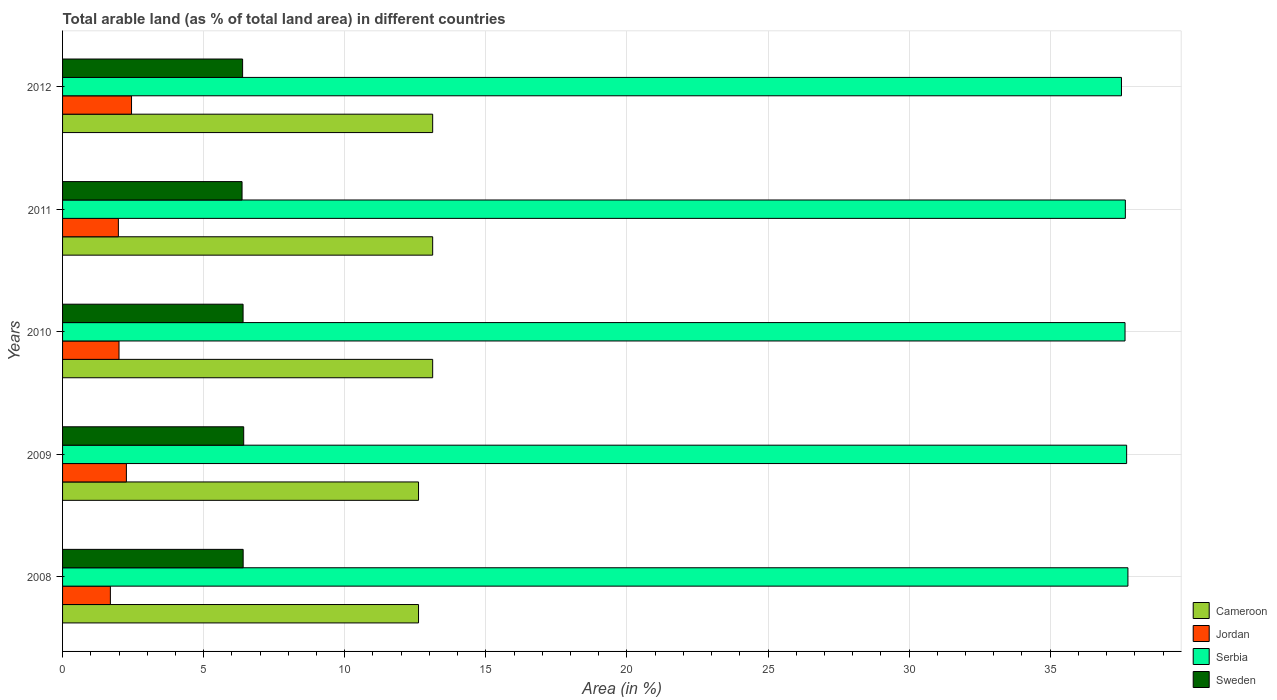How many different coloured bars are there?
Your answer should be compact. 4. How many groups of bars are there?
Offer a very short reply. 5. Are the number of bars per tick equal to the number of legend labels?
Make the answer very short. Yes. How many bars are there on the 2nd tick from the bottom?
Offer a terse response. 4. What is the label of the 4th group of bars from the top?
Your answer should be very brief. 2009. What is the percentage of arable land in Jordan in 2012?
Your answer should be very brief. 2.44. Across all years, what is the maximum percentage of arable land in Serbia?
Your response must be concise. 37.75. Across all years, what is the minimum percentage of arable land in Serbia?
Offer a terse response. 37.53. In which year was the percentage of arable land in Sweden maximum?
Your answer should be compact. 2009. In which year was the percentage of arable land in Serbia minimum?
Your answer should be very brief. 2012. What is the total percentage of arable land in Jordan in the graph?
Your answer should be compact. 10.38. What is the difference between the percentage of arable land in Sweden in 2009 and that in 2011?
Provide a short and direct response. 0.06. What is the difference between the percentage of arable land in Jordan in 2010 and the percentage of arable land in Cameroon in 2012?
Provide a short and direct response. -11.12. What is the average percentage of arable land in Jordan per year?
Keep it short and to the point. 2.08. In the year 2009, what is the difference between the percentage of arable land in Serbia and percentage of arable land in Cameroon?
Make the answer very short. 25.09. What is the ratio of the percentage of arable land in Sweden in 2010 to that in 2012?
Your answer should be very brief. 1. What is the difference between the highest and the second highest percentage of arable land in Sweden?
Your answer should be very brief. 0.02. What is the difference between the highest and the lowest percentage of arable land in Sweden?
Your response must be concise. 0.06. In how many years, is the percentage of arable land in Jordan greater than the average percentage of arable land in Jordan taken over all years?
Give a very brief answer. 2. Is the sum of the percentage of arable land in Jordan in 2009 and 2010 greater than the maximum percentage of arable land in Serbia across all years?
Offer a very short reply. No. What does the 1st bar from the bottom in 2008 represents?
Give a very brief answer. Cameroon. Is it the case that in every year, the sum of the percentage of arable land in Serbia and percentage of arable land in Sweden is greater than the percentage of arable land in Cameroon?
Your answer should be compact. Yes. How many bars are there?
Make the answer very short. 20. How are the legend labels stacked?
Your answer should be compact. Vertical. What is the title of the graph?
Keep it short and to the point. Total arable land (as % of total land area) in different countries. What is the label or title of the X-axis?
Provide a short and direct response. Area (in %). What is the Area (in %) in Cameroon in 2008?
Offer a very short reply. 12.61. What is the Area (in %) of Jordan in 2008?
Your response must be concise. 1.69. What is the Area (in %) of Serbia in 2008?
Make the answer very short. 37.75. What is the Area (in %) of Sweden in 2008?
Your answer should be very brief. 6.4. What is the Area (in %) in Cameroon in 2009?
Your response must be concise. 12.61. What is the Area (in %) in Jordan in 2009?
Provide a succinct answer. 2.26. What is the Area (in %) in Serbia in 2009?
Your answer should be compact. 37.71. What is the Area (in %) of Sweden in 2009?
Your answer should be very brief. 6.42. What is the Area (in %) in Cameroon in 2010?
Make the answer very short. 13.12. What is the Area (in %) in Jordan in 2010?
Offer a terse response. 2. What is the Area (in %) of Serbia in 2010?
Make the answer very short. 37.65. What is the Area (in %) of Sweden in 2010?
Ensure brevity in your answer.  6.4. What is the Area (in %) in Cameroon in 2011?
Your response must be concise. 13.12. What is the Area (in %) in Jordan in 2011?
Provide a short and direct response. 1.98. What is the Area (in %) of Serbia in 2011?
Your answer should be very brief. 37.66. What is the Area (in %) of Sweden in 2011?
Make the answer very short. 6.36. What is the Area (in %) of Cameroon in 2012?
Ensure brevity in your answer.  13.12. What is the Area (in %) of Jordan in 2012?
Your answer should be compact. 2.44. What is the Area (in %) of Serbia in 2012?
Offer a very short reply. 37.53. What is the Area (in %) of Sweden in 2012?
Ensure brevity in your answer.  6.38. Across all years, what is the maximum Area (in %) of Cameroon?
Offer a very short reply. 13.12. Across all years, what is the maximum Area (in %) in Jordan?
Offer a very short reply. 2.44. Across all years, what is the maximum Area (in %) in Serbia?
Your answer should be very brief. 37.75. Across all years, what is the maximum Area (in %) of Sweden?
Your answer should be very brief. 6.42. Across all years, what is the minimum Area (in %) of Cameroon?
Provide a short and direct response. 12.61. Across all years, what is the minimum Area (in %) in Jordan?
Ensure brevity in your answer.  1.69. Across all years, what is the minimum Area (in %) in Serbia?
Make the answer very short. 37.53. Across all years, what is the minimum Area (in %) of Sweden?
Give a very brief answer. 6.36. What is the total Area (in %) of Cameroon in the graph?
Provide a succinct answer. 64.58. What is the total Area (in %) of Jordan in the graph?
Offer a very short reply. 10.38. What is the total Area (in %) of Serbia in the graph?
Provide a succinct answer. 188.3. What is the total Area (in %) of Sweden in the graph?
Ensure brevity in your answer.  31.96. What is the difference between the Area (in %) in Jordan in 2008 and that in 2009?
Ensure brevity in your answer.  -0.57. What is the difference between the Area (in %) in Serbia in 2008 and that in 2009?
Keep it short and to the point. 0.05. What is the difference between the Area (in %) in Sweden in 2008 and that in 2009?
Ensure brevity in your answer.  -0.02. What is the difference between the Area (in %) in Cameroon in 2008 and that in 2010?
Offer a very short reply. -0.5. What is the difference between the Area (in %) of Jordan in 2008 and that in 2010?
Your response must be concise. -0.31. What is the difference between the Area (in %) of Serbia in 2008 and that in 2010?
Give a very brief answer. 0.1. What is the difference between the Area (in %) in Sweden in 2008 and that in 2010?
Offer a very short reply. 0. What is the difference between the Area (in %) in Cameroon in 2008 and that in 2011?
Your answer should be compact. -0.5. What is the difference between the Area (in %) of Jordan in 2008 and that in 2011?
Your response must be concise. -0.28. What is the difference between the Area (in %) in Serbia in 2008 and that in 2011?
Keep it short and to the point. 0.09. What is the difference between the Area (in %) of Sweden in 2008 and that in 2011?
Make the answer very short. 0.04. What is the difference between the Area (in %) in Cameroon in 2008 and that in 2012?
Ensure brevity in your answer.  -0.5. What is the difference between the Area (in %) in Jordan in 2008 and that in 2012?
Keep it short and to the point. -0.75. What is the difference between the Area (in %) of Serbia in 2008 and that in 2012?
Ensure brevity in your answer.  0.23. What is the difference between the Area (in %) in Sweden in 2008 and that in 2012?
Provide a succinct answer. 0.02. What is the difference between the Area (in %) of Cameroon in 2009 and that in 2010?
Your answer should be very brief. -0.5. What is the difference between the Area (in %) in Jordan in 2009 and that in 2010?
Your answer should be very brief. 0.26. What is the difference between the Area (in %) of Serbia in 2009 and that in 2010?
Give a very brief answer. 0.06. What is the difference between the Area (in %) in Sweden in 2009 and that in 2010?
Your answer should be very brief. 0.02. What is the difference between the Area (in %) in Cameroon in 2009 and that in 2011?
Your response must be concise. -0.5. What is the difference between the Area (in %) in Jordan in 2009 and that in 2011?
Make the answer very short. 0.28. What is the difference between the Area (in %) of Serbia in 2009 and that in 2011?
Keep it short and to the point. 0.05. What is the difference between the Area (in %) in Sweden in 2009 and that in 2011?
Your answer should be compact. 0.06. What is the difference between the Area (in %) in Cameroon in 2009 and that in 2012?
Provide a short and direct response. -0.5. What is the difference between the Area (in %) in Jordan in 2009 and that in 2012?
Provide a succinct answer. -0.18. What is the difference between the Area (in %) of Serbia in 2009 and that in 2012?
Offer a very short reply. 0.18. What is the difference between the Area (in %) in Sweden in 2009 and that in 2012?
Give a very brief answer. 0.04. What is the difference between the Area (in %) in Jordan in 2010 and that in 2011?
Your answer should be compact. 0.02. What is the difference between the Area (in %) in Serbia in 2010 and that in 2011?
Keep it short and to the point. -0.01. What is the difference between the Area (in %) of Sweden in 2010 and that in 2011?
Ensure brevity in your answer.  0.04. What is the difference between the Area (in %) in Jordan in 2010 and that in 2012?
Provide a succinct answer. -0.44. What is the difference between the Area (in %) in Serbia in 2010 and that in 2012?
Offer a very short reply. 0.13. What is the difference between the Area (in %) in Sweden in 2010 and that in 2012?
Your response must be concise. 0.02. What is the difference between the Area (in %) in Cameroon in 2011 and that in 2012?
Your response must be concise. 0. What is the difference between the Area (in %) in Jordan in 2011 and that in 2012?
Ensure brevity in your answer.  -0.47. What is the difference between the Area (in %) of Serbia in 2011 and that in 2012?
Offer a terse response. 0.14. What is the difference between the Area (in %) in Sweden in 2011 and that in 2012?
Provide a succinct answer. -0.02. What is the difference between the Area (in %) in Cameroon in 2008 and the Area (in %) in Jordan in 2009?
Provide a succinct answer. 10.35. What is the difference between the Area (in %) in Cameroon in 2008 and the Area (in %) in Serbia in 2009?
Offer a terse response. -25.09. What is the difference between the Area (in %) in Cameroon in 2008 and the Area (in %) in Sweden in 2009?
Offer a very short reply. 6.2. What is the difference between the Area (in %) in Jordan in 2008 and the Area (in %) in Serbia in 2009?
Your answer should be very brief. -36.01. What is the difference between the Area (in %) in Jordan in 2008 and the Area (in %) in Sweden in 2009?
Provide a short and direct response. -4.72. What is the difference between the Area (in %) of Serbia in 2008 and the Area (in %) of Sweden in 2009?
Your answer should be very brief. 31.34. What is the difference between the Area (in %) in Cameroon in 2008 and the Area (in %) in Jordan in 2010?
Your answer should be compact. 10.61. What is the difference between the Area (in %) in Cameroon in 2008 and the Area (in %) in Serbia in 2010?
Provide a short and direct response. -25.04. What is the difference between the Area (in %) in Cameroon in 2008 and the Area (in %) in Sweden in 2010?
Your response must be concise. 6.22. What is the difference between the Area (in %) of Jordan in 2008 and the Area (in %) of Serbia in 2010?
Ensure brevity in your answer.  -35.96. What is the difference between the Area (in %) of Jordan in 2008 and the Area (in %) of Sweden in 2010?
Keep it short and to the point. -4.7. What is the difference between the Area (in %) of Serbia in 2008 and the Area (in %) of Sweden in 2010?
Offer a very short reply. 31.36. What is the difference between the Area (in %) in Cameroon in 2008 and the Area (in %) in Jordan in 2011?
Offer a terse response. 10.64. What is the difference between the Area (in %) of Cameroon in 2008 and the Area (in %) of Serbia in 2011?
Offer a terse response. -25.05. What is the difference between the Area (in %) in Cameroon in 2008 and the Area (in %) in Sweden in 2011?
Provide a succinct answer. 6.25. What is the difference between the Area (in %) of Jordan in 2008 and the Area (in %) of Serbia in 2011?
Your response must be concise. -35.97. What is the difference between the Area (in %) of Jordan in 2008 and the Area (in %) of Sweden in 2011?
Offer a terse response. -4.67. What is the difference between the Area (in %) of Serbia in 2008 and the Area (in %) of Sweden in 2011?
Offer a terse response. 31.39. What is the difference between the Area (in %) in Cameroon in 2008 and the Area (in %) in Jordan in 2012?
Make the answer very short. 10.17. What is the difference between the Area (in %) in Cameroon in 2008 and the Area (in %) in Serbia in 2012?
Offer a very short reply. -24.91. What is the difference between the Area (in %) in Cameroon in 2008 and the Area (in %) in Sweden in 2012?
Your response must be concise. 6.23. What is the difference between the Area (in %) of Jordan in 2008 and the Area (in %) of Serbia in 2012?
Ensure brevity in your answer.  -35.83. What is the difference between the Area (in %) of Jordan in 2008 and the Area (in %) of Sweden in 2012?
Your response must be concise. -4.69. What is the difference between the Area (in %) of Serbia in 2008 and the Area (in %) of Sweden in 2012?
Provide a short and direct response. 31.37. What is the difference between the Area (in %) of Cameroon in 2009 and the Area (in %) of Jordan in 2010?
Keep it short and to the point. 10.61. What is the difference between the Area (in %) in Cameroon in 2009 and the Area (in %) in Serbia in 2010?
Provide a short and direct response. -25.04. What is the difference between the Area (in %) in Cameroon in 2009 and the Area (in %) in Sweden in 2010?
Your response must be concise. 6.22. What is the difference between the Area (in %) in Jordan in 2009 and the Area (in %) in Serbia in 2010?
Your answer should be compact. -35.39. What is the difference between the Area (in %) in Jordan in 2009 and the Area (in %) in Sweden in 2010?
Offer a terse response. -4.14. What is the difference between the Area (in %) of Serbia in 2009 and the Area (in %) of Sweden in 2010?
Offer a terse response. 31.31. What is the difference between the Area (in %) of Cameroon in 2009 and the Area (in %) of Jordan in 2011?
Your answer should be compact. 10.64. What is the difference between the Area (in %) in Cameroon in 2009 and the Area (in %) in Serbia in 2011?
Make the answer very short. -25.05. What is the difference between the Area (in %) in Cameroon in 2009 and the Area (in %) in Sweden in 2011?
Your answer should be compact. 6.25. What is the difference between the Area (in %) of Jordan in 2009 and the Area (in %) of Serbia in 2011?
Keep it short and to the point. -35.4. What is the difference between the Area (in %) in Jordan in 2009 and the Area (in %) in Sweden in 2011?
Give a very brief answer. -4.1. What is the difference between the Area (in %) of Serbia in 2009 and the Area (in %) of Sweden in 2011?
Keep it short and to the point. 31.35. What is the difference between the Area (in %) in Cameroon in 2009 and the Area (in %) in Jordan in 2012?
Make the answer very short. 10.17. What is the difference between the Area (in %) in Cameroon in 2009 and the Area (in %) in Serbia in 2012?
Provide a short and direct response. -24.91. What is the difference between the Area (in %) in Cameroon in 2009 and the Area (in %) in Sweden in 2012?
Provide a succinct answer. 6.23. What is the difference between the Area (in %) of Jordan in 2009 and the Area (in %) of Serbia in 2012?
Keep it short and to the point. -35.26. What is the difference between the Area (in %) in Jordan in 2009 and the Area (in %) in Sweden in 2012?
Your answer should be compact. -4.12. What is the difference between the Area (in %) in Serbia in 2009 and the Area (in %) in Sweden in 2012?
Your answer should be very brief. 31.33. What is the difference between the Area (in %) of Cameroon in 2010 and the Area (in %) of Jordan in 2011?
Your answer should be very brief. 11.14. What is the difference between the Area (in %) of Cameroon in 2010 and the Area (in %) of Serbia in 2011?
Your response must be concise. -24.55. What is the difference between the Area (in %) of Cameroon in 2010 and the Area (in %) of Sweden in 2011?
Offer a very short reply. 6.76. What is the difference between the Area (in %) of Jordan in 2010 and the Area (in %) of Serbia in 2011?
Offer a terse response. -35.66. What is the difference between the Area (in %) of Jordan in 2010 and the Area (in %) of Sweden in 2011?
Your response must be concise. -4.36. What is the difference between the Area (in %) in Serbia in 2010 and the Area (in %) in Sweden in 2011?
Your response must be concise. 31.29. What is the difference between the Area (in %) in Cameroon in 2010 and the Area (in %) in Jordan in 2012?
Keep it short and to the point. 10.67. What is the difference between the Area (in %) in Cameroon in 2010 and the Area (in %) in Serbia in 2012?
Provide a short and direct response. -24.41. What is the difference between the Area (in %) of Cameroon in 2010 and the Area (in %) of Sweden in 2012?
Give a very brief answer. 6.74. What is the difference between the Area (in %) in Jordan in 2010 and the Area (in %) in Serbia in 2012?
Provide a succinct answer. -35.53. What is the difference between the Area (in %) in Jordan in 2010 and the Area (in %) in Sweden in 2012?
Offer a very short reply. -4.38. What is the difference between the Area (in %) of Serbia in 2010 and the Area (in %) of Sweden in 2012?
Your answer should be compact. 31.27. What is the difference between the Area (in %) in Cameroon in 2011 and the Area (in %) in Jordan in 2012?
Your answer should be compact. 10.67. What is the difference between the Area (in %) in Cameroon in 2011 and the Area (in %) in Serbia in 2012?
Provide a succinct answer. -24.41. What is the difference between the Area (in %) in Cameroon in 2011 and the Area (in %) in Sweden in 2012?
Your answer should be compact. 6.74. What is the difference between the Area (in %) in Jordan in 2011 and the Area (in %) in Serbia in 2012?
Ensure brevity in your answer.  -35.55. What is the difference between the Area (in %) in Jordan in 2011 and the Area (in %) in Sweden in 2012?
Make the answer very short. -4.4. What is the difference between the Area (in %) of Serbia in 2011 and the Area (in %) of Sweden in 2012?
Provide a succinct answer. 31.28. What is the average Area (in %) of Cameroon per year?
Provide a short and direct response. 12.92. What is the average Area (in %) of Jordan per year?
Provide a short and direct response. 2.08. What is the average Area (in %) of Serbia per year?
Make the answer very short. 37.66. What is the average Area (in %) of Sweden per year?
Your response must be concise. 6.39. In the year 2008, what is the difference between the Area (in %) of Cameroon and Area (in %) of Jordan?
Ensure brevity in your answer.  10.92. In the year 2008, what is the difference between the Area (in %) in Cameroon and Area (in %) in Serbia?
Give a very brief answer. -25.14. In the year 2008, what is the difference between the Area (in %) in Cameroon and Area (in %) in Sweden?
Give a very brief answer. 6.21. In the year 2008, what is the difference between the Area (in %) of Jordan and Area (in %) of Serbia?
Give a very brief answer. -36.06. In the year 2008, what is the difference between the Area (in %) of Jordan and Area (in %) of Sweden?
Your answer should be very brief. -4.71. In the year 2008, what is the difference between the Area (in %) of Serbia and Area (in %) of Sweden?
Offer a very short reply. 31.35. In the year 2009, what is the difference between the Area (in %) in Cameroon and Area (in %) in Jordan?
Ensure brevity in your answer.  10.35. In the year 2009, what is the difference between the Area (in %) in Cameroon and Area (in %) in Serbia?
Offer a very short reply. -25.09. In the year 2009, what is the difference between the Area (in %) of Cameroon and Area (in %) of Sweden?
Your response must be concise. 6.2. In the year 2009, what is the difference between the Area (in %) of Jordan and Area (in %) of Serbia?
Provide a short and direct response. -35.45. In the year 2009, what is the difference between the Area (in %) in Jordan and Area (in %) in Sweden?
Offer a very short reply. -4.16. In the year 2009, what is the difference between the Area (in %) of Serbia and Area (in %) of Sweden?
Provide a short and direct response. 31.29. In the year 2010, what is the difference between the Area (in %) of Cameroon and Area (in %) of Jordan?
Your answer should be compact. 11.12. In the year 2010, what is the difference between the Area (in %) of Cameroon and Area (in %) of Serbia?
Your response must be concise. -24.54. In the year 2010, what is the difference between the Area (in %) of Cameroon and Area (in %) of Sweden?
Your answer should be very brief. 6.72. In the year 2010, what is the difference between the Area (in %) of Jordan and Area (in %) of Serbia?
Give a very brief answer. -35.65. In the year 2010, what is the difference between the Area (in %) of Jordan and Area (in %) of Sweden?
Make the answer very short. -4.4. In the year 2010, what is the difference between the Area (in %) in Serbia and Area (in %) in Sweden?
Ensure brevity in your answer.  31.25. In the year 2011, what is the difference between the Area (in %) in Cameroon and Area (in %) in Jordan?
Offer a very short reply. 11.14. In the year 2011, what is the difference between the Area (in %) in Cameroon and Area (in %) in Serbia?
Provide a short and direct response. -24.55. In the year 2011, what is the difference between the Area (in %) of Cameroon and Area (in %) of Sweden?
Ensure brevity in your answer.  6.76. In the year 2011, what is the difference between the Area (in %) in Jordan and Area (in %) in Serbia?
Your answer should be compact. -35.69. In the year 2011, what is the difference between the Area (in %) in Jordan and Area (in %) in Sweden?
Provide a succinct answer. -4.38. In the year 2011, what is the difference between the Area (in %) of Serbia and Area (in %) of Sweden?
Make the answer very short. 31.3. In the year 2012, what is the difference between the Area (in %) in Cameroon and Area (in %) in Jordan?
Your response must be concise. 10.67. In the year 2012, what is the difference between the Area (in %) in Cameroon and Area (in %) in Serbia?
Your response must be concise. -24.41. In the year 2012, what is the difference between the Area (in %) in Cameroon and Area (in %) in Sweden?
Your response must be concise. 6.74. In the year 2012, what is the difference between the Area (in %) of Jordan and Area (in %) of Serbia?
Offer a terse response. -35.08. In the year 2012, what is the difference between the Area (in %) in Jordan and Area (in %) in Sweden?
Your answer should be compact. -3.94. In the year 2012, what is the difference between the Area (in %) of Serbia and Area (in %) of Sweden?
Your response must be concise. 31.15. What is the ratio of the Area (in %) in Jordan in 2008 to that in 2009?
Offer a very short reply. 0.75. What is the ratio of the Area (in %) of Serbia in 2008 to that in 2009?
Make the answer very short. 1. What is the ratio of the Area (in %) in Cameroon in 2008 to that in 2010?
Ensure brevity in your answer.  0.96. What is the ratio of the Area (in %) of Jordan in 2008 to that in 2010?
Make the answer very short. 0.85. What is the ratio of the Area (in %) in Serbia in 2008 to that in 2010?
Your answer should be very brief. 1. What is the ratio of the Area (in %) of Sweden in 2008 to that in 2010?
Keep it short and to the point. 1. What is the ratio of the Area (in %) of Cameroon in 2008 to that in 2011?
Your response must be concise. 0.96. What is the ratio of the Area (in %) in Jordan in 2008 to that in 2011?
Keep it short and to the point. 0.86. What is the ratio of the Area (in %) of Cameroon in 2008 to that in 2012?
Offer a terse response. 0.96. What is the ratio of the Area (in %) of Jordan in 2008 to that in 2012?
Keep it short and to the point. 0.69. What is the ratio of the Area (in %) of Sweden in 2008 to that in 2012?
Your response must be concise. 1. What is the ratio of the Area (in %) of Cameroon in 2009 to that in 2010?
Keep it short and to the point. 0.96. What is the ratio of the Area (in %) in Jordan in 2009 to that in 2010?
Offer a very short reply. 1.13. What is the ratio of the Area (in %) in Serbia in 2009 to that in 2010?
Make the answer very short. 1. What is the ratio of the Area (in %) in Sweden in 2009 to that in 2010?
Offer a very short reply. 1. What is the ratio of the Area (in %) of Cameroon in 2009 to that in 2011?
Provide a short and direct response. 0.96. What is the ratio of the Area (in %) in Jordan in 2009 to that in 2011?
Your response must be concise. 1.14. What is the ratio of the Area (in %) in Sweden in 2009 to that in 2011?
Your answer should be compact. 1.01. What is the ratio of the Area (in %) of Cameroon in 2009 to that in 2012?
Give a very brief answer. 0.96. What is the ratio of the Area (in %) of Jordan in 2009 to that in 2012?
Your answer should be very brief. 0.93. What is the ratio of the Area (in %) in Serbia in 2009 to that in 2012?
Ensure brevity in your answer.  1. What is the ratio of the Area (in %) of Sweden in 2009 to that in 2012?
Provide a short and direct response. 1.01. What is the ratio of the Area (in %) in Jordan in 2010 to that in 2011?
Your answer should be compact. 1.01. What is the ratio of the Area (in %) of Cameroon in 2010 to that in 2012?
Give a very brief answer. 1. What is the ratio of the Area (in %) of Jordan in 2010 to that in 2012?
Your answer should be compact. 0.82. What is the ratio of the Area (in %) in Sweden in 2010 to that in 2012?
Provide a short and direct response. 1. What is the ratio of the Area (in %) in Jordan in 2011 to that in 2012?
Your answer should be compact. 0.81. What is the ratio of the Area (in %) in Serbia in 2011 to that in 2012?
Offer a very short reply. 1. What is the ratio of the Area (in %) in Sweden in 2011 to that in 2012?
Your response must be concise. 1. What is the difference between the highest and the second highest Area (in %) of Cameroon?
Your answer should be very brief. 0. What is the difference between the highest and the second highest Area (in %) of Jordan?
Your response must be concise. 0.18. What is the difference between the highest and the second highest Area (in %) in Serbia?
Make the answer very short. 0.05. What is the difference between the highest and the second highest Area (in %) of Sweden?
Your answer should be very brief. 0.02. What is the difference between the highest and the lowest Area (in %) in Cameroon?
Your answer should be compact. 0.5. What is the difference between the highest and the lowest Area (in %) in Serbia?
Give a very brief answer. 0.23. What is the difference between the highest and the lowest Area (in %) of Sweden?
Your answer should be very brief. 0.06. 